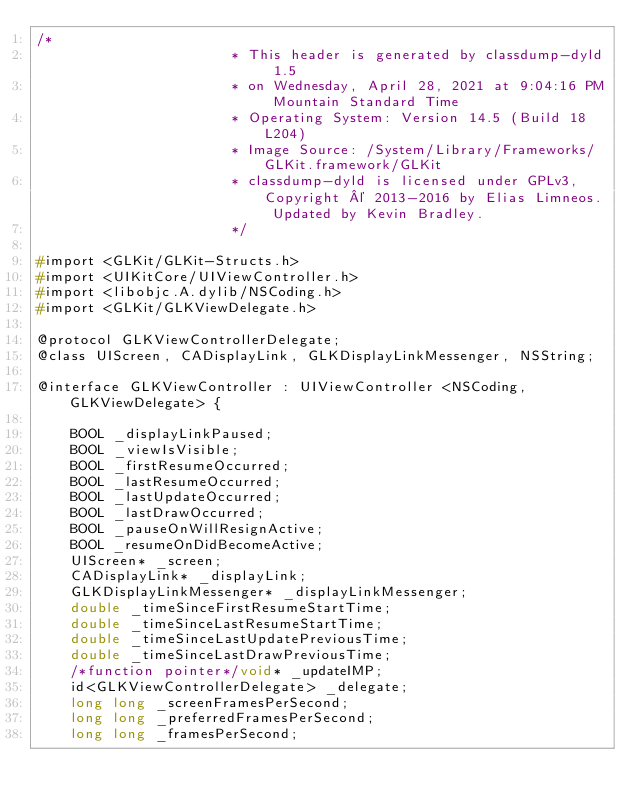Convert code to text. <code><loc_0><loc_0><loc_500><loc_500><_C_>/*
                       * This header is generated by classdump-dyld 1.5
                       * on Wednesday, April 28, 2021 at 9:04:16 PM Mountain Standard Time
                       * Operating System: Version 14.5 (Build 18L204)
                       * Image Source: /System/Library/Frameworks/GLKit.framework/GLKit
                       * classdump-dyld is licensed under GPLv3, Copyright © 2013-2016 by Elias Limneos. Updated by Kevin Bradley.
                       */

#import <GLKit/GLKit-Structs.h>
#import <UIKitCore/UIViewController.h>
#import <libobjc.A.dylib/NSCoding.h>
#import <GLKit/GLKViewDelegate.h>

@protocol GLKViewControllerDelegate;
@class UIScreen, CADisplayLink, GLKDisplayLinkMessenger, NSString;

@interface GLKViewController : UIViewController <NSCoding, GLKViewDelegate> {

	BOOL _displayLinkPaused;
	BOOL _viewIsVisible;
	BOOL _firstResumeOccurred;
	BOOL _lastResumeOccurred;
	BOOL _lastUpdateOccurred;
	BOOL _lastDrawOccurred;
	BOOL _pauseOnWillResignActive;
	BOOL _resumeOnDidBecomeActive;
	UIScreen* _screen;
	CADisplayLink* _displayLink;
	GLKDisplayLinkMessenger* _displayLinkMessenger;
	double _timeSinceFirstResumeStartTime;
	double _timeSinceLastResumeStartTime;
	double _timeSinceLastUpdatePreviousTime;
	double _timeSinceLastDrawPreviousTime;
	/*function pointer*/void* _updateIMP;
	id<GLKViewControllerDelegate> _delegate;
	long long _screenFramesPerSecond;
	long long _preferredFramesPerSecond;
	long long _framesPerSecond;</code> 